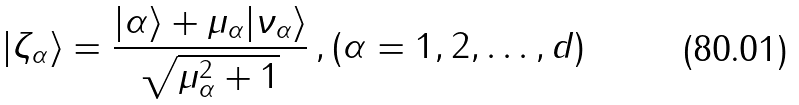<formula> <loc_0><loc_0><loc_500><loc_500>| \zeta _ { \alpha } \rangle = \frac { | \alpha \rangle + \mu _ { \alpha } | \nu _ { \alpha } \rangle } { \sqrt { \mu ^ { 2 } _ { \alpha } + 1 } } \, , ( \alpha = 1 , 2 , \dots , d )</formula> 